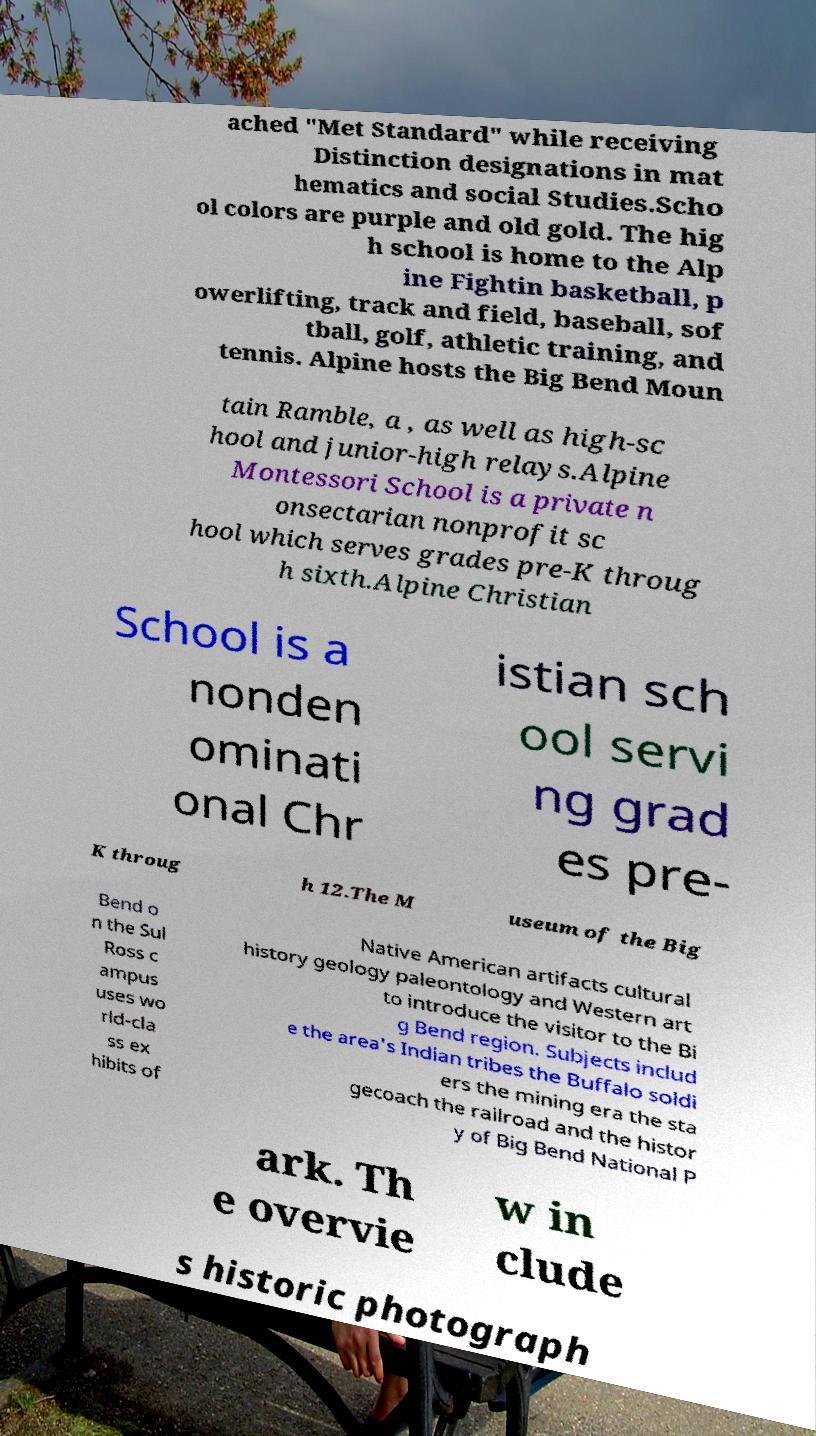There's text embedded in this image that I need extracted. Can you transcribe it verbatim? ached "Met Standard" while receiving Distinction designations in mat hematics and social Studies.Scho ol colors are purple and old gold. The hig h school is home to the Alp ine Fightin basketball, p owerlifting, track and field, baseball, sof tball, golf, athletic training, and tennis. Alpine hosts the Big Bend Moun tain Ramble, a , as well as high-sc hool and junior-high relays.Alpine Montessori School is a private n onsectarian nonprofit sc hool which serves grades pre-K throug h sixth.Alpine Christian School is a nonden ominati onal Chr istian sch ool servi ng grad es pre- K throug h 12.The M useum of the Big Bend o n the Sul Ross c ampus uses wo rld-cla ss ex hibits of Native American artifacts cultural history geology paleontology and Western art to introduce the visitor to the Bi g Bend region. Subjects includ e the area's Indian tribes the Buffalo soldi ers the mining era the sta gecoach the railroad and the histor y of Big Bend National P ark. Th e overvie w in clude s historic photograph 